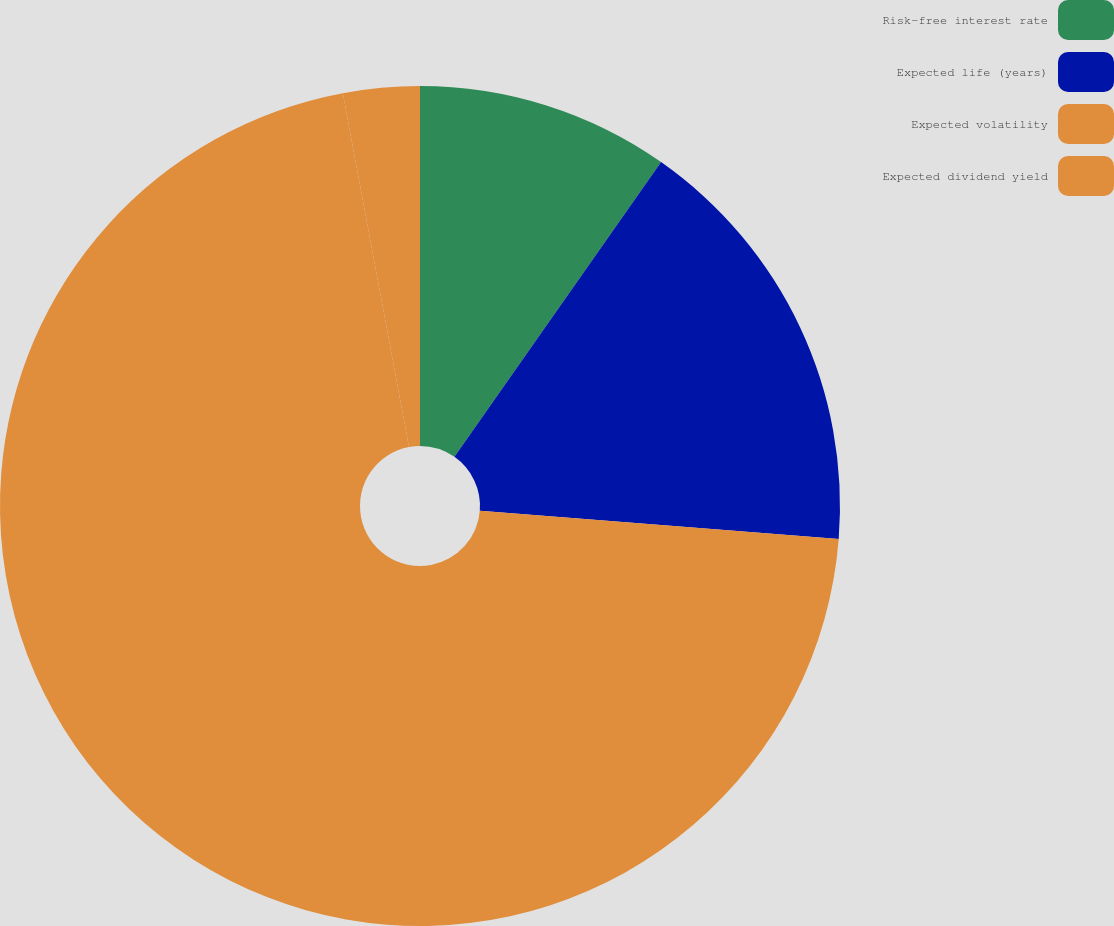Convert chart. <chart><loc_0><loc_0><loc_500><loc_500><pie_chart><fcel>Risk-free interest rate<fcel>Expected life (years)<fcel>Expected volatility<fcel>Expected dividend yield<nl><fcel>9.73%<fcel>16.52%<fcel>70.81%<fcel>2.94%<nl></chart> 